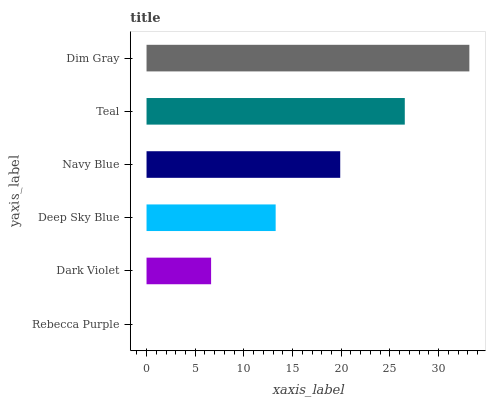Is Rebecca Purple the minimum?
Answer yes or no. Yes. Is Dim Gray the maximum?
Answer yes or no. Yes. Is Dark Violet the minimum?
Answer yes or no. No. Is Dark Violet the maximum?
Answer yes or no. No. Is Dark Violet greater than Rebecca Purple?
Answer yes or no. Yes. Is Rebecca Purple less than Dark Violet?
Answer yes or no. Yes. Is Rebecca Purple greater than Dark Violet?
Answer yes or no. No. Is Dark Violet less than Rebecca Purple?
Answer yes or no. No. Is Navy Blue the high median?
Answer yes or no. Yes. Is Deep Sky Blue the low median?
Answer yes or no. Yes. Is Rebecca Purple the high median?
Answer yes or no. No. Is Teal the low median?
Answer yes or no. No. 